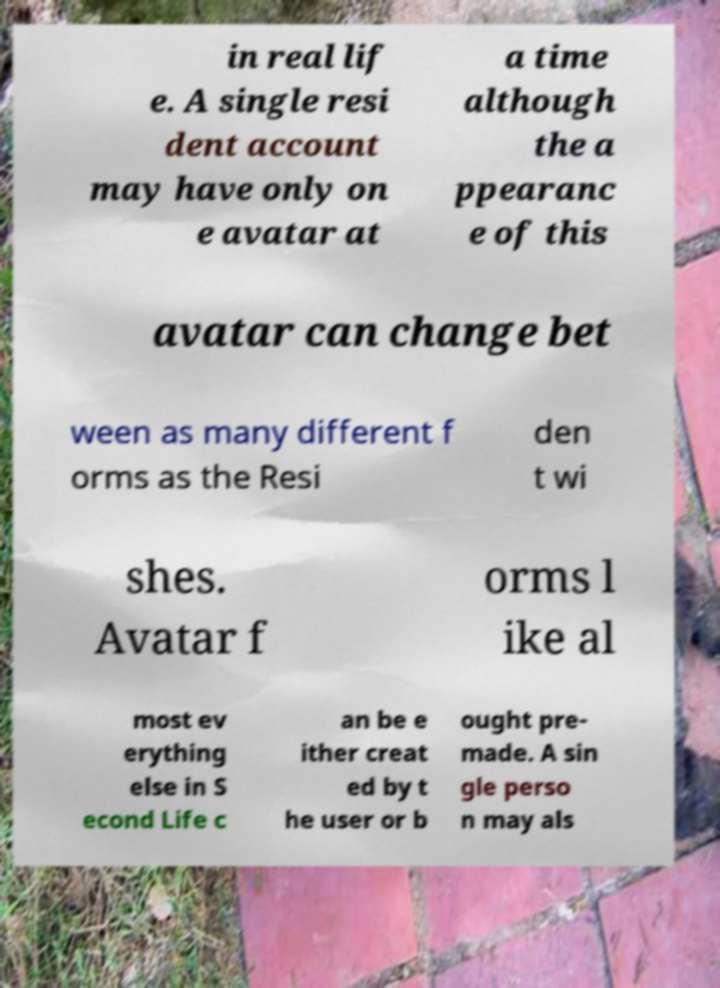Can you accurately transcribe the text from the provided image for me? in real lif e. A single resi dent account may have only on e avatar at a time although the a ppearanc e of this avatar can change bet ween as many different f orms as the Resi den t wi shes. Avatar f orms l ike al most ev erything else in S econd Life c an be e ither creat ed by t he user or b ought pre- made. A sin gle perso n may als 